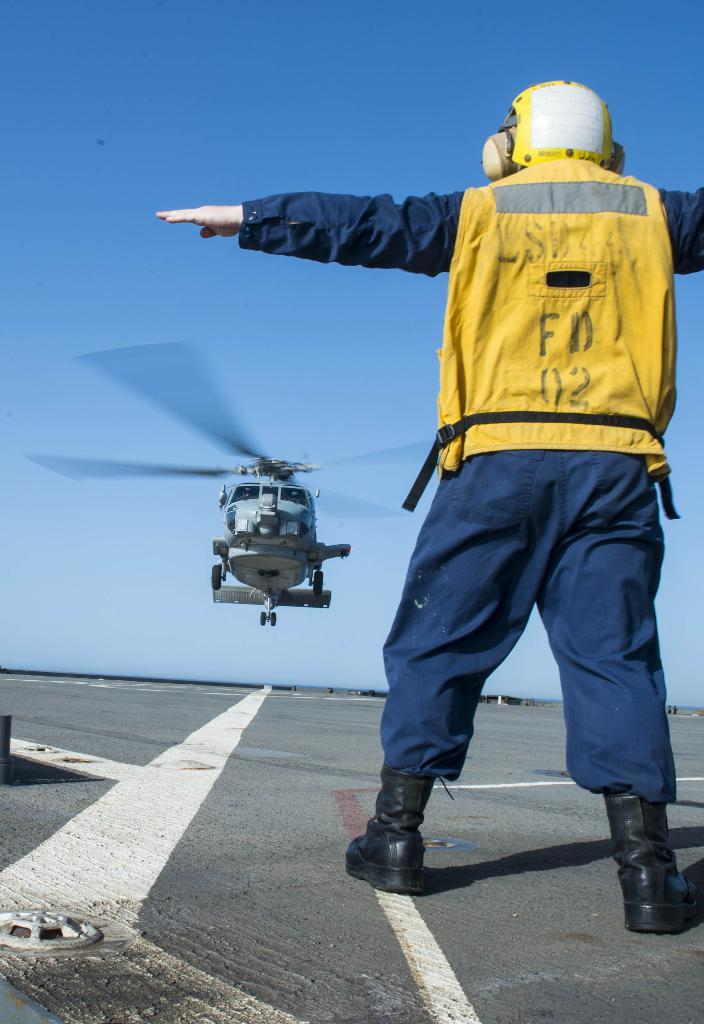<image>
Relay a brief, clear account of the picture shown. Flight director FD 02 directs a helicopter in landing on the runway. 